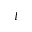<formula> <loc_0><loc_0><loc_500><loc_500>I</formula> 